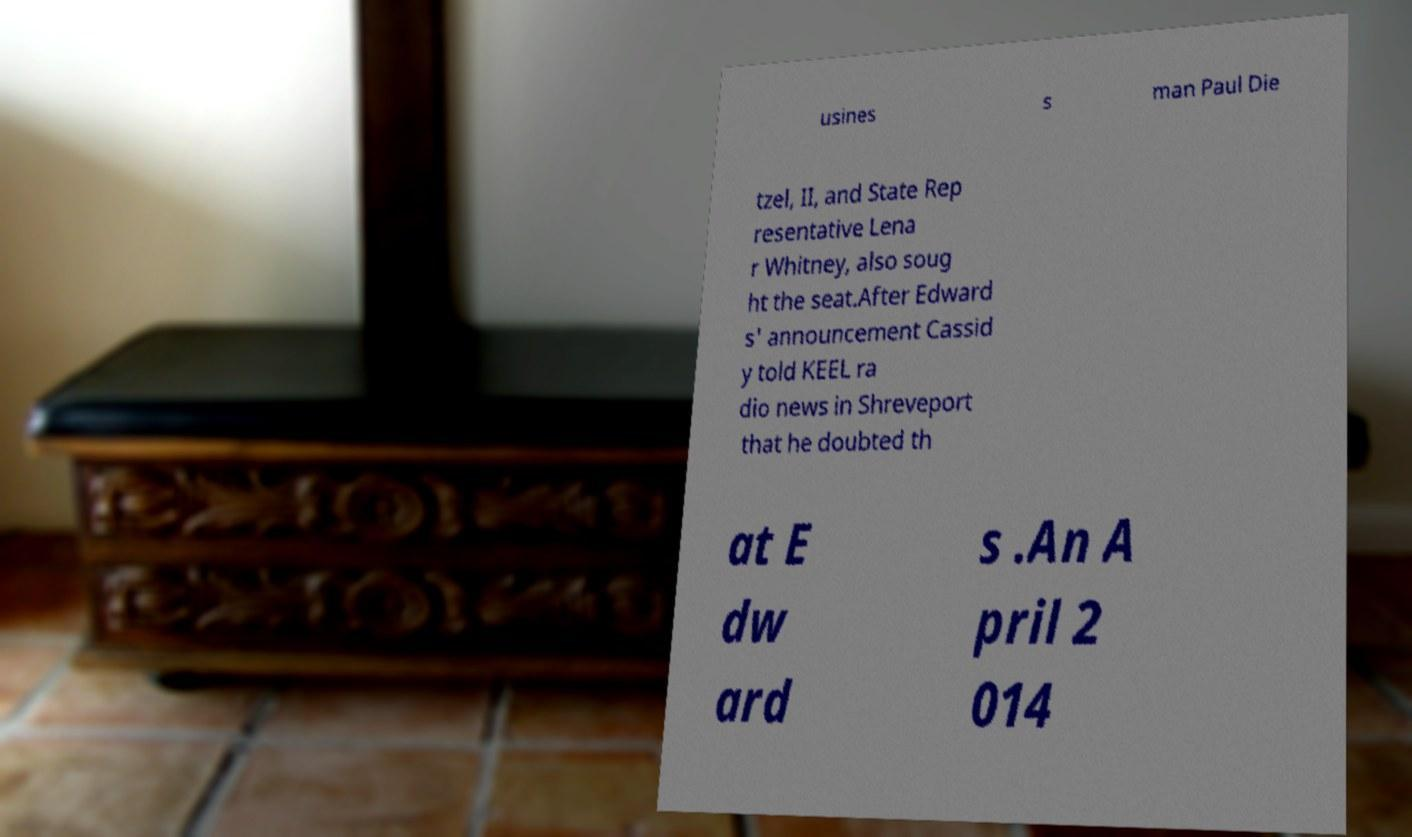There's text embedded in this image that I need extracted. Can you transcribe it verbatim? usines s man Paul Die tzel, II, and State Rep resentative Lena r Whitney, also soug ht the seat.After Edward s' announcement Cassid y told KEEL ra dio news in Shreveport that he doubted th at E dw ard s .An A pril 2 014 